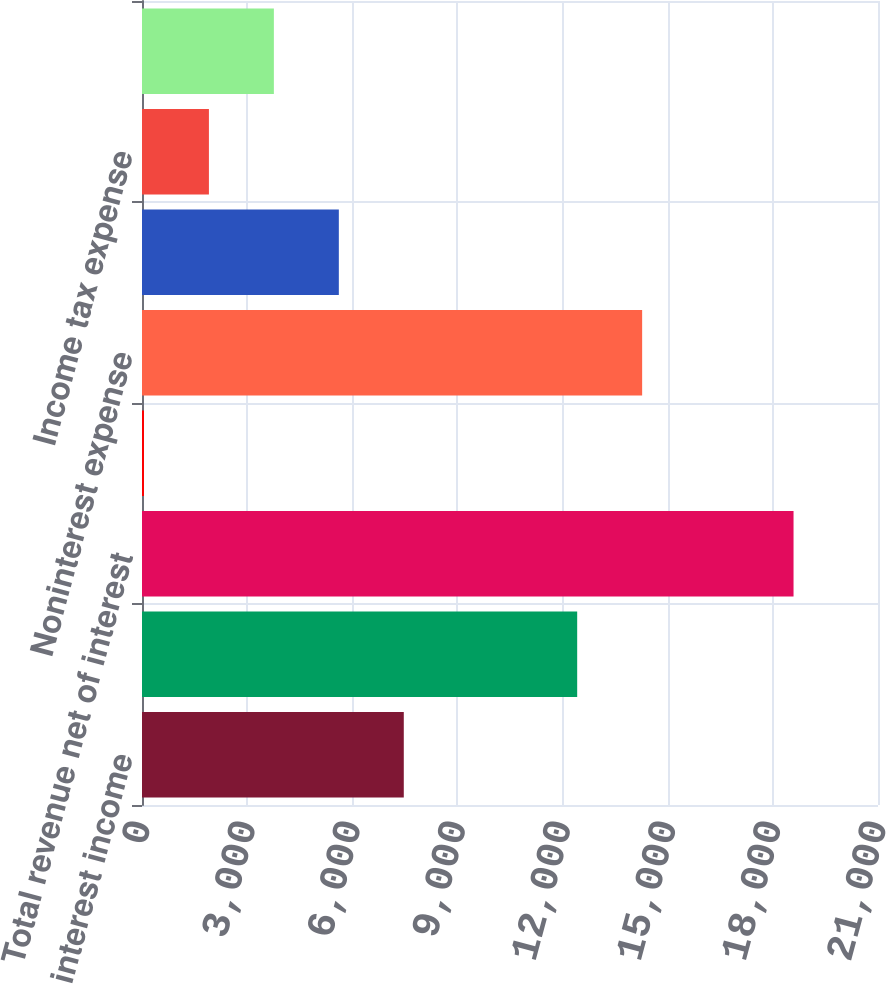<chart> <loc_0><loc_0><loc_500><loc_500><bar_chart><fcel>Net interest income<fcel>Noninterest income<fcel>Total revenue net of interest<fcel>Provision for credit losses<fcel>Noninterest expense<fcel>Income before income taxes<fcel>Income tax expense<fcel>Net income<nl><fcel>7469.6<fcel>12417<fcel>18590<fcel>56<fcel>14270.4<fcel>5616.2<fcel>1909.4<fcel>3762.8<nl></chart> 